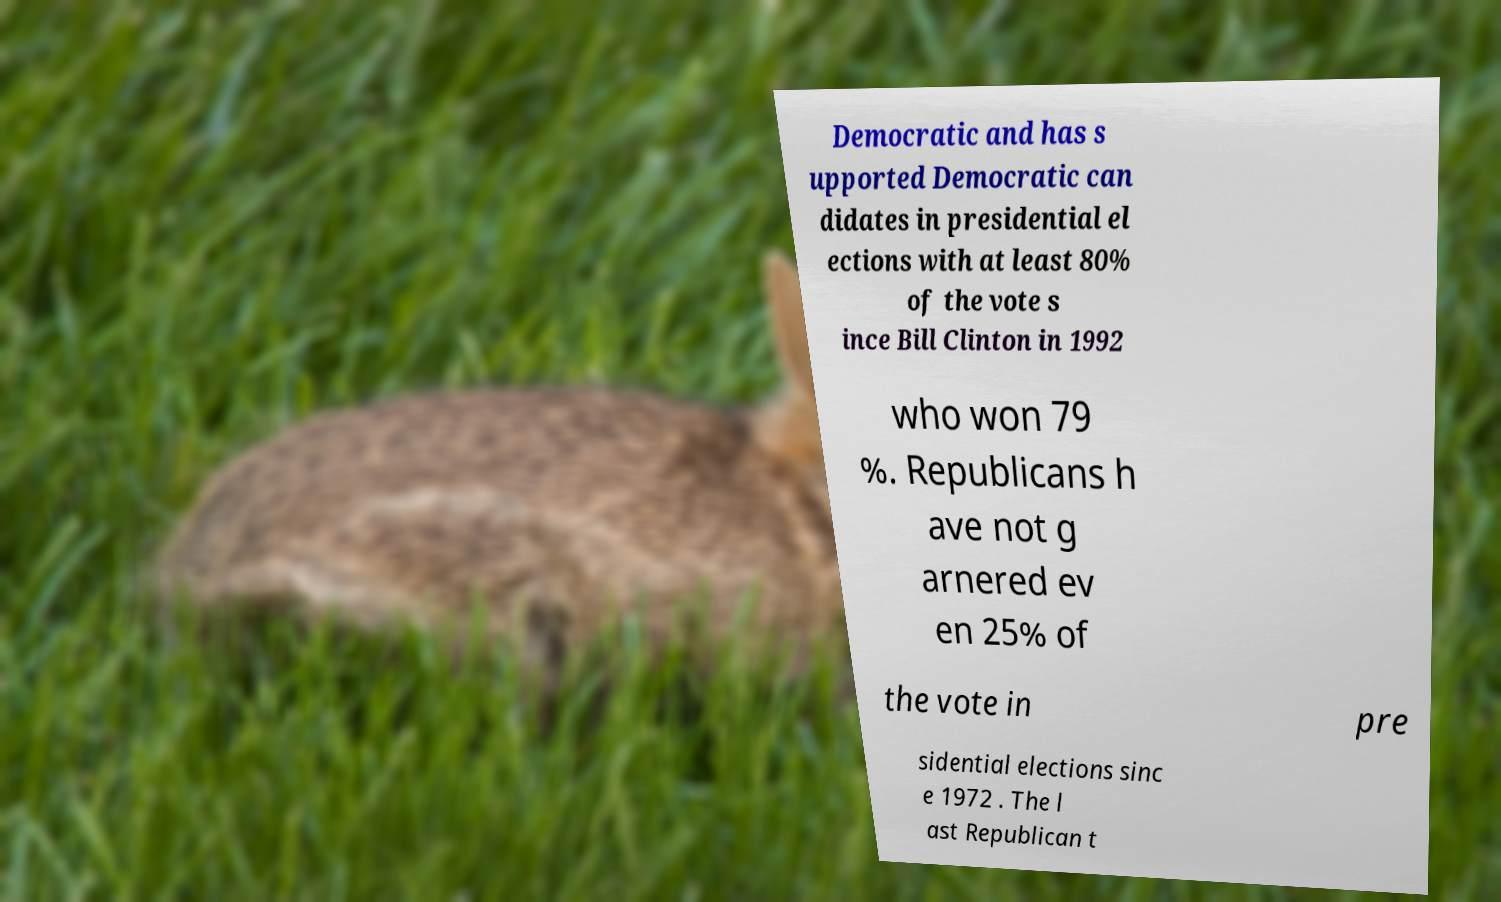Please read and relay the text visible in this image. What does it say? Democratic and has s upported Democratic can didates in presidential el ections with at least 80% of the vote s ince Bill Clinton in 1992 who won 79 %. Republicans h ave not g arnered ev en 25% of the vote in pre sidential elections sinc e 1972 . The l ast Republican t 